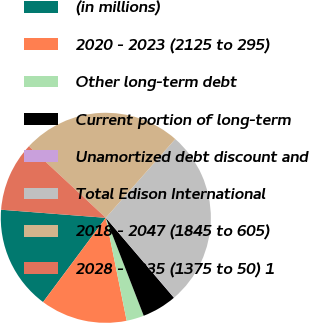<chart> <loc_0><loc_0><loc_500><loc_500><pie_chart><fcel>(in millions)<fcel>2020 - 2023 (2125 to 295)<fcel>Other long-term debt<fcel>Current portion of long-term<fcel>Unamortized debt discount and<fcel>Total Edison International<fcel>2018 - 2047 (1845 to 605)<fcel>2028 - 2035 (1375 to 50) 1<nl><fcel>16.04%<fcel>13.37%<fcel>2.69%<fcel>5.36%<fcel>0.02%<fcel>27.24%<fcel>24.57%<fcel>10.7%<nl></chart> 